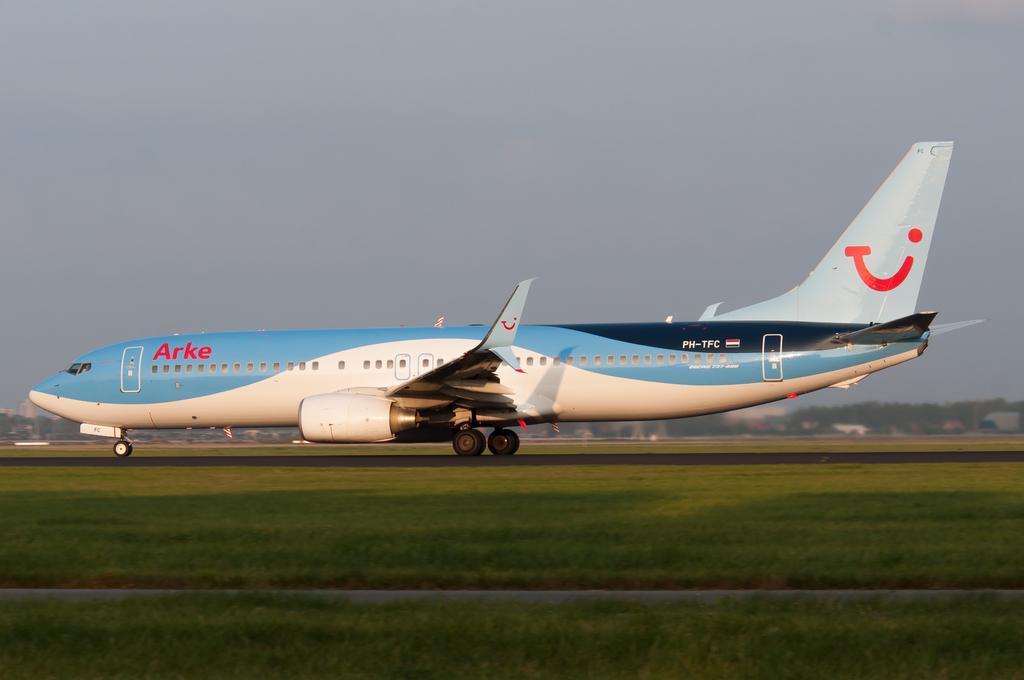What is the name of the airline?
Offer a terse response. Arke. 